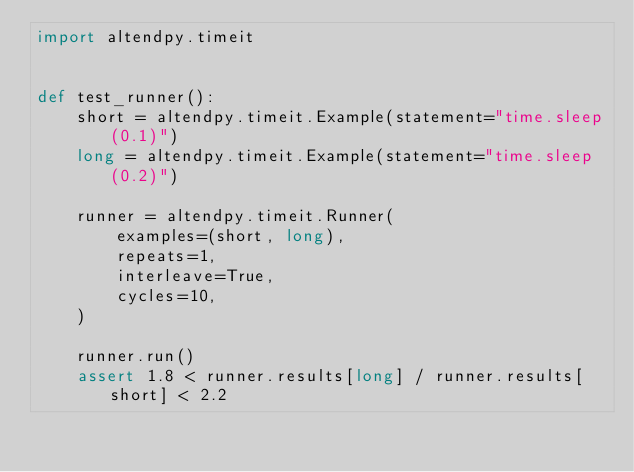Convert code to text. <code><loc_0><loc_0><loc_500><loc_500><_Python_>import altendpy.timeit


def test_runner():
    short = altendpy.timeit.Example(statement="time.sleep(0.1)")
    long = altendpy.timeit.Example(statement="time.sleep(0.2)")

    runner = altendpy.timeit.Runner(
        examples=(short, long),
        repeats=1,
        interleave=True,
        cycles=10,
    )

    runner.run()
    assert 1.8 < runner.results[long] / runner.results[short] < 2.2
</code> 